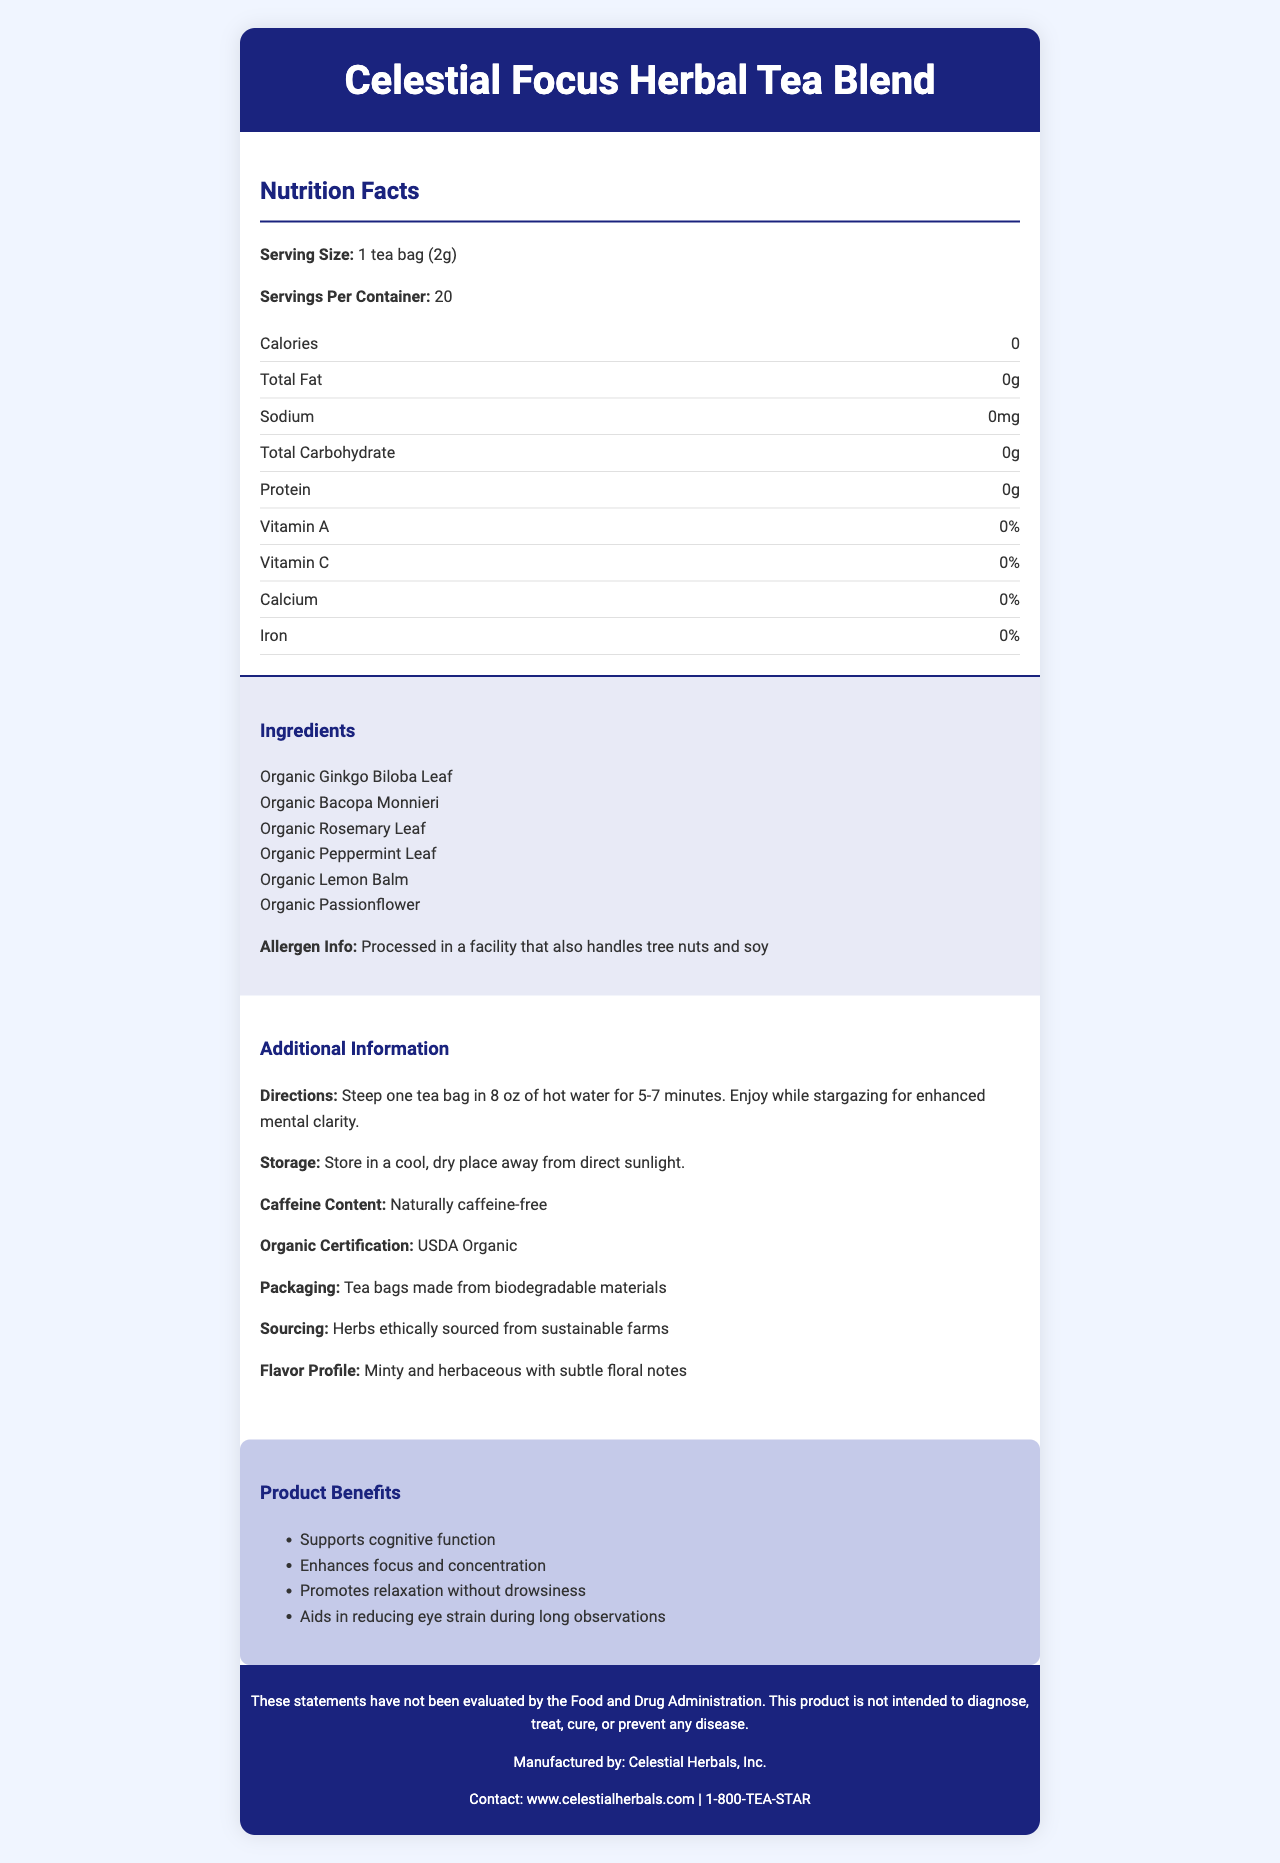What is the serving size of the Celestial Focus Herbal Tea Blend? The serving size is explicitly mentioned in the nutrition facts section, stating "Serving Size: 1 tea bag (2g)".
Answer: 1 tea bag (2g) How many servings are there per container? The document states "Servings Per Container: 20".
Answer: 20 Is this herbal tea blend calorie-free? The document lists "Calories: 0", confirming that the herbal tea is calorie-free.
Answer: Yes What are two key herbs mentioned in the ingredient list? The ingredient list includes these two herbs as part of its composition.
Answer: Organic Ginkgo Biloba Leaf and Organic Bacopa Monnieri What is the recommended steeping time for the tea? The directions state to steep one tea bag in 8 oz of hot water for 5-7 minutes.
Answer: 5-7 minutes Which of the following ingredients is included in the tea blend? A. Chamomile B. Organic Peppermint Leaf C. Black Tea The ingredient list includes "Organic Peppermint Leaf", whereas Chamomile and Black Tea are not listed.
Answer: B. Organic Peppermint Leaf What percentage of Vitamin C is in this tea? A. 0% B. 10% C. 25% D. 50% The nutrition facts section indicates "Vitamin C: 0%".
Answer: A. 0% Does this product contain caffeine? The additional information section clearly states "Caffeine Content: Naturally caffeine-free".
Answer: No Is the Celestial Focus Herbal Tea Blend certified organic? The additional information specifies "Organic Certification: USDA Organic".
Answer: Yes Summarize the main benefits of the Celestial Focus Herbal Tea Blend. The product benefits section outlines these key points, detailing how the tea is designed to support mental clarity and relaxation specifically for activities like stargazing.
Answer: The tea supports cognitive function, enhances focus and concentration, promotes relaxation without causing drowsiness, and aids in reducing eye strain during night sky observations. What materials are the tea bags made from? The additional information section includes "Tea bags made from biodegradable materials", indicating the eco-friendly nature of the packaging.
Answer: Biodegradable materials Where are the herbs in this tea sourced from? The additional info states "Herbs ethically sourced from sustainable farms", emphasizing ethical and sustainable sourcing practices.
Answer: Sustainable farms Does this product contain any allergens according to the label? The allergen info states that the product is processed in a facility that also handles tree nuts and soy.
Answer: Yes Can this product diagnose, treat, cure, or prevent any disease? The disclaimer explicitly states that the product is not intended to diagnose, treat, cure, or prevent any disease.
Answer: No What is the flavor profile of the tea? The additional information outlines the flavor profile as "Minty and herbaceous with subtle floral notes".
Answer: Minty and herbaceous with subtle floral notes Which company manufactures the Celestial Focus Herbal Tea Blend? The footer of the document states the manufacturer as Celestial Herbals, Inc.
Answer: Celestial Herbals, Inc. What is the net weight of one tea bag? The document only specifies the serving size (2g) but does not explicitly state that this is the net weight.
Answer: Not enough information What type of packaging is used for the tea bags? The document mentions that the tea bags are made from biodegradable materials.
Answer: Biodegradable materials 